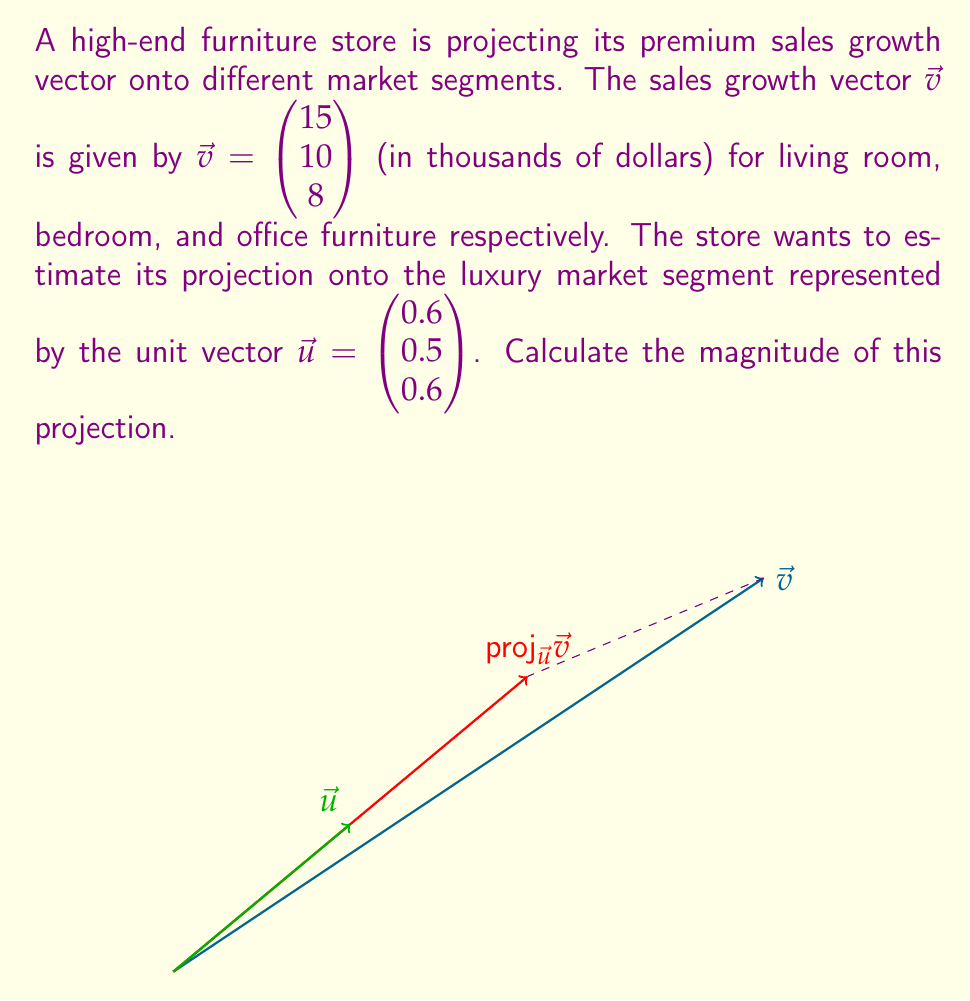Show me your answer to this math problem. To solve this problem, we'll use the formula for vector projection:

$$\text{proj}_{\vec{u}}\vec{v} = \frac{\vec{v} \cdot \vec{u}}{\|\vec{u}\|^2} \vec{u}$$

Since $\vec{u}$ is a unit vector, $\|\vec{u}\|^2 = 1$, so our formula simplifies to:

$$\text{proj}_{\vec{u}}\vec{v} = (\vec{v} \cdot \vec{u}) \vec{u}$$

Steps:
1) Calculate the dot product $\vec{v} \cdot \vec{u}$:
   $$\vec{v} \cdot \vec{u} = 15(0.6) + 10(0.5) + 8(0.6) = 9 + 5 + 4.8 = 18.8$$

2) The projection vector is:
   $$\text{proj}_{\vec{u}}\vec{v} = 18.8 \begin{pmatrix} 0.6 \\ 0.5 \\ 0.6 \end{pmatrix} = \begin{pmatrix} 11.28 \\ 9.4 \\ 11.28 \end{pmatrix}$$

3) To find the magnitude of this projection, we calculate:
   $$\|\text{proj}_{\vec{u}}\vec{v}\| = \sqrt{11.28^2 + 9.4^2 + 11.28^2} = 18.8$$

Therefore, the magnitude of the projection is 18.8 thousand dollars.
Answer: $18.8$ thousand dollars 